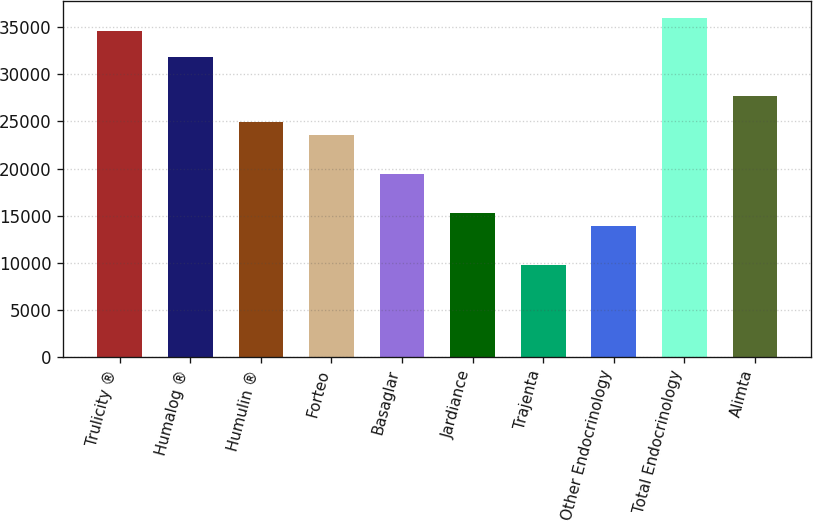Convert chart. <chart><loc_0><loc_0><loc_500><loc_500><bar_chart><fcel>Trulicity ®<fcel>Humalog ®<fcel>Humulin ®<fcel>Forteo<fcel>Basaglar<fcel>Jardiance<fcel>Trajenta<fcel>Other Endocrinology<fcel>Total Endocrinology<fcel>Alimta<nl><fcel>34633.7<fcel>31865.9<fcel>24946.4<fcel>23562.5<fcel>19410.8<fcel>15259.1<fcel>9723.5<fcel>13875.2<fcel>36017.6<fcel>27714.2<nl></chart> 